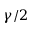<formula> <loc_0><loc_0><loc_500><loc_500>\gamma / 2</formula> 